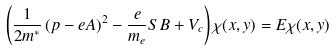<formula> <loc_0><loc_0><loc_500><loc_500>\left ( \frac { 1 } { 2 m ^ { \ast } } \left ( { p } - e { A } \right ) ^ { 2 } - \frac { e } { m _ { e } } { S B } + V _ { c } \right ) \chi ( x , y ) = E \chi ( x , y )</formula> 